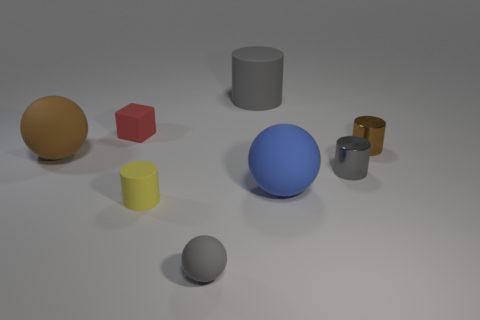Describe the texture of the objects. Do they all look smooth? From the image, all of the objects have a smooth surface finish with no visible texture, showing clean and clear reflections and shadows. Does the image give any indication of the size of these objects? Without a reference point or scale in the image, it's challenging to determine the exact size of these objects, but relative to each other, we can discern size differences, such as the blue sphere being the largest and the grey cylinder appearing tall but narrow. 